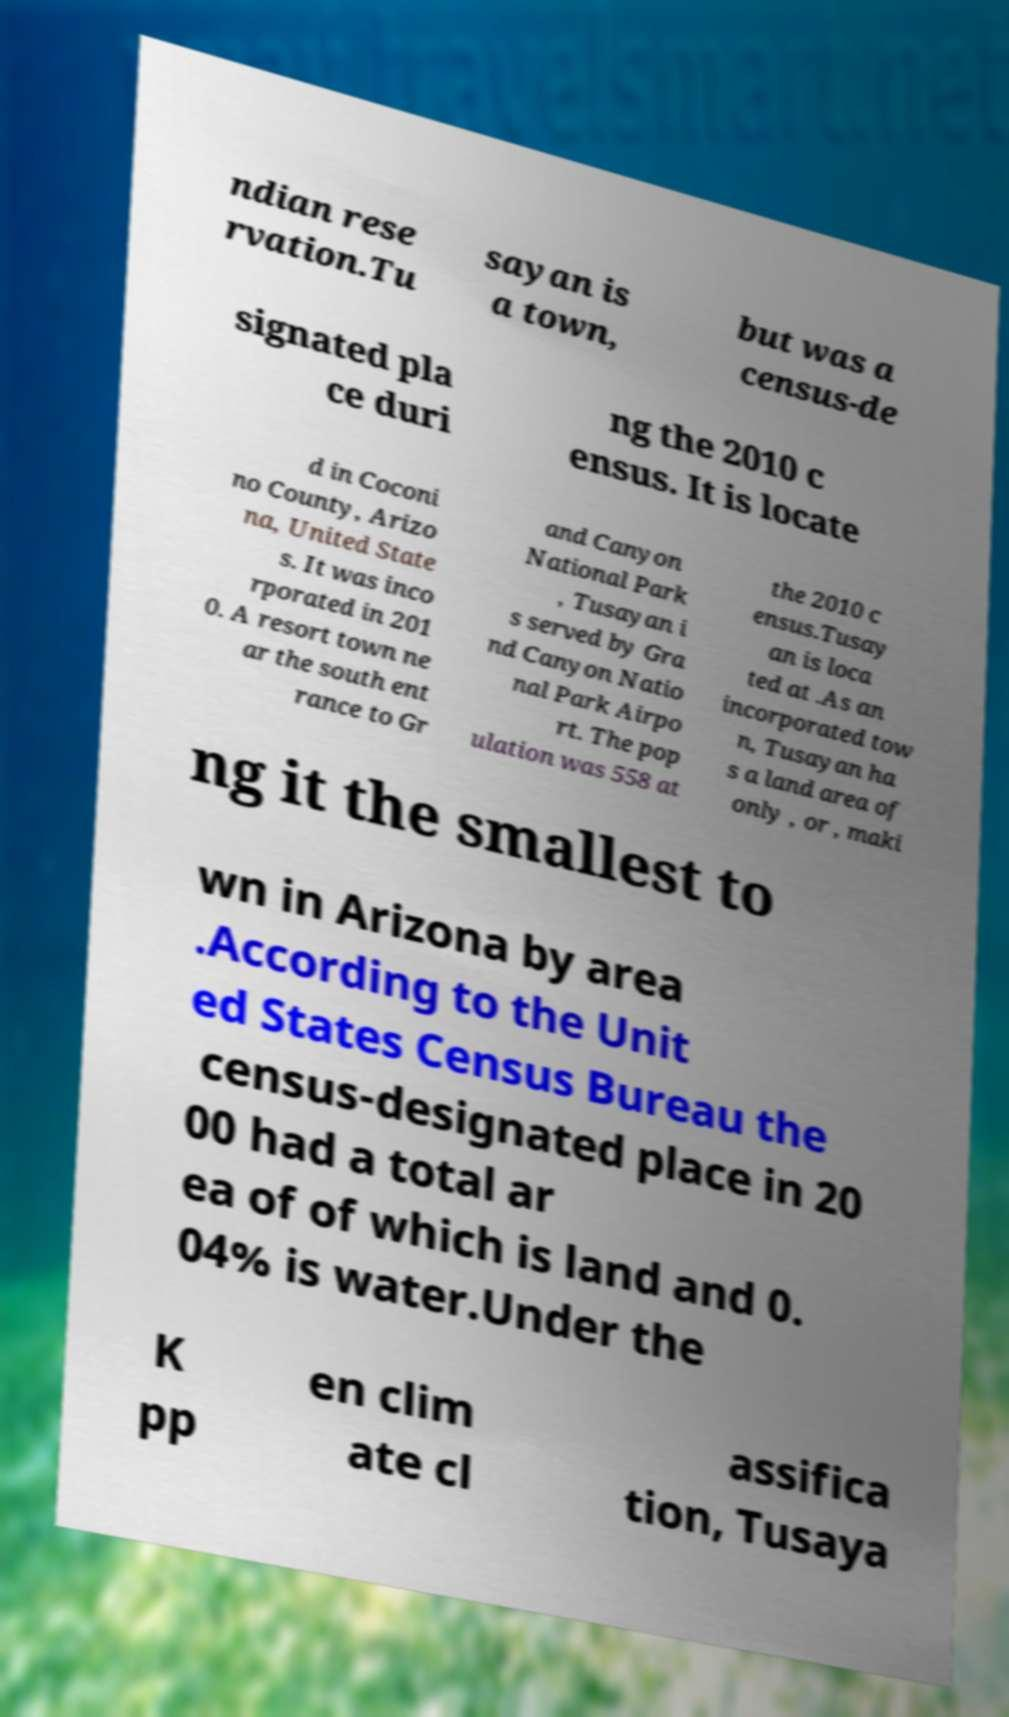Could you assist in decoding the text presented in this image and type it out clearly? ndian rese rvation.Tu sayan is a town, but was a census-de signated pla ce duri ng the 2010 c ensus. It is locate d in Coconi no County, Arizo na, United State s. It was inco rporated in 201 0. A resort town ne ar the south ent rance to Gr and Canyon National Park , Tusayan i s served by Gra nd Canyon Natio nal Park Airpo rt. The pop ulation was 558 at the 2010 c ensus.Tusay an is loca ted at .As an incorporated tow n, Tusayan ha s a land area of only , or , maki ng it the smallest to wn in Arizona by area .According to the Unit ed States Census Bureau the census-designated place in 20 00 had a total ar ea of of which is land and 0. 04% is water.Under the K pp en clim ate cl assifica tion, Tusaya 